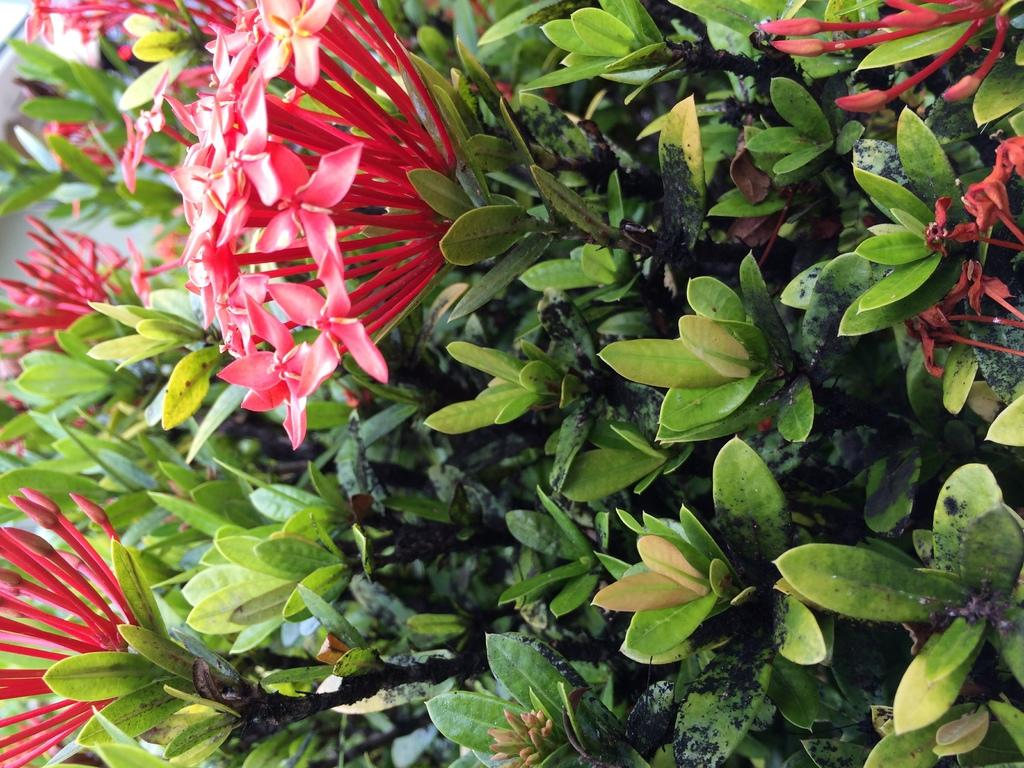What type of living organisms can be seen in the image? There are flowers and plants in the image. Can you describe the plants in the image? The image contains flowers, which are a type of plant. Are there any other plants visible in the image besides the flowers? The facts provided do not specify any other plants, only flowers. What type of mine is depicted in the image? There is no mine present in the image; it features flowers and plants. How many employees work for the company in the image? There is no company or employees present in the image; it features flowers and plants. 